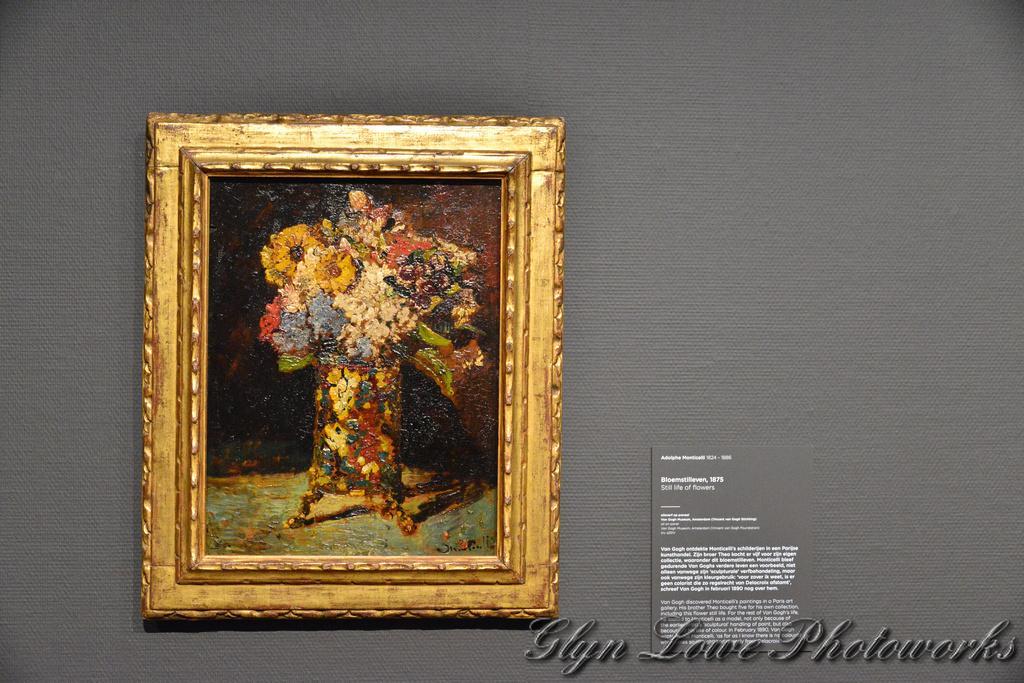Could you give a brief overview of what you see in this image? It looks like a grey wall and on the wall there is a photo frame and a board. On the image there is a watermark. 